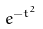<formula> <loc_0><loc_0><loc_500><loc_500>e ^ { - t ^ { 2 } }</formula> 